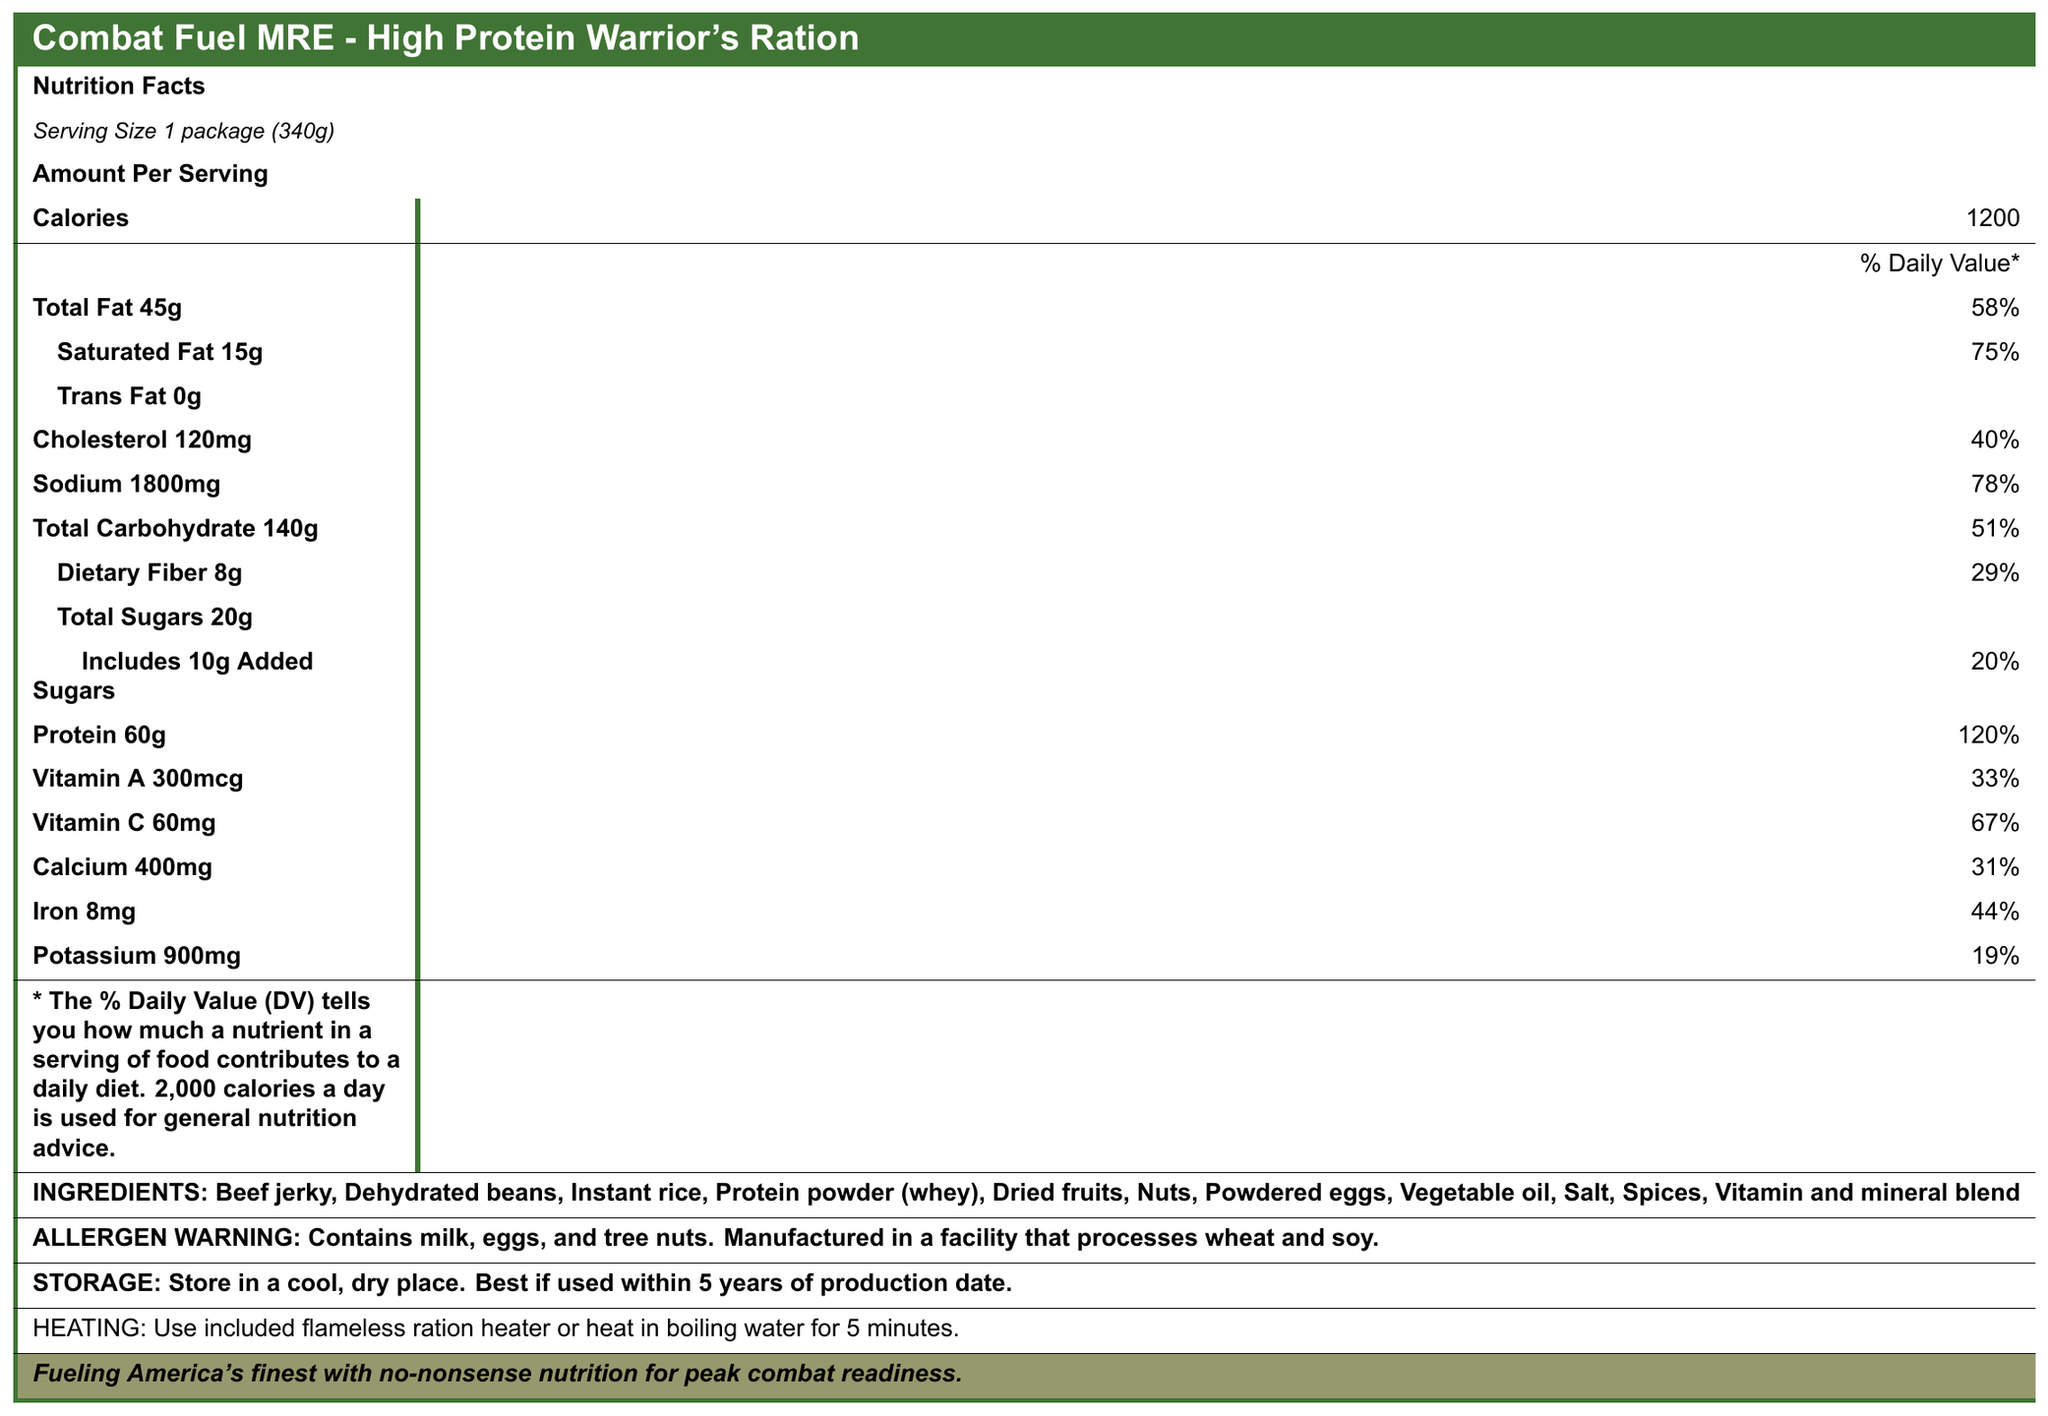what is the serving size of the Combat Fuel MRE? The serving size is specified under "Serving Size" in the document and is listed as "1 package (340g)".
Answer: 1 package (340g) how many calories are in one serving of the Combat Fuel MRE? The number of calories per serving is stated as "Calories 1200" in the document.
Answer: 1200 how much protein does one package of Combat Fuel MRE contain? The document lists "Protein 60g" under the nutrition facts.
Answer: 60g what is the percent daily value for saturated fat in the Combat Fuel MRE? The percent daily value for saturated fat is shown as "Saturated Fat 15g 75%" in the document.
Answer: 75% what ingredients are included in the Combat Fuel MRE? The ingredients are listed under "INGREDIENTS" in the document.
Answer: Beef jerky, Dehydrated beans, Instant rice, Protein powder (whey), Dried fruits, Nuts, Powdered eggs, Vegetable oil, Salt, Spices, Vitamin and mineral blend how much potassium is in one serving of the Combat Fuel MRE? The potassium content is specified as "Potassium 900mg" in the document.
Answer: 900mg in what kind of facility is the Combat Fuel MRE manufactured? The allergen warning states that it is "Manufactured in a facility that processes wheat and soy."
Answer: Manufactured in a facility that processes wheat and soy how should the Combat Fuel MRE be stored? The storage instructions are provided in the document under "STORAGE."
Answer: Store in a cool, dry place. Best if used within 5 years of production date. which of the following nutrients has the highest percent daily value in the Combat Fuel MRE?
A. Protein
B. Sodium
C. Vitamin C The document indicates that Protein has a percent daily value of 120%, which is higher than Sodium (78%) and Vitamin C (67%).
Answer: A. Protein which of the following items is included as a side dish in the Combat Fuel MRE?
1. Crackers
2. Instant rice
3. Peanut butter
4. Chewing gum The side dish listed in the MRE contents is "Instant rice."
Answer: 2. Instant rice does the document specify the amount of trans fat in the Combat Fuel MRE? The document states "Trans Fat 0g" but does not provide a percent daily value or any further details.
Answer: No summarize the information provided in the Combat Fuel MRE document. The summary encapsulates the purpose and content of the document, focusing on the nutritional information, storage and usage guidelines, and the inclusion of various meal components.
Answer: This document presents the nutrition facts, ingredients, allergen warning, storage instructions, heating instructions, and the mission statement for the Combat Fuel MRE - High Protein Warrior's Ration. It contains details of the calories, macronutrients, vitamins, and minerals per serving, along with the list of included items such as the main entrée, side dish, and additional snacks and conveniences. The document aims to inform the consumer about the nutritional value and proper handling of the MRE to maintain optimal combat readiness. what is the exact production date of the Combat Fuel MRE mentioned in the document? The document provides storage instructions but does not specify the exact production date.
Answer: Not enough information 